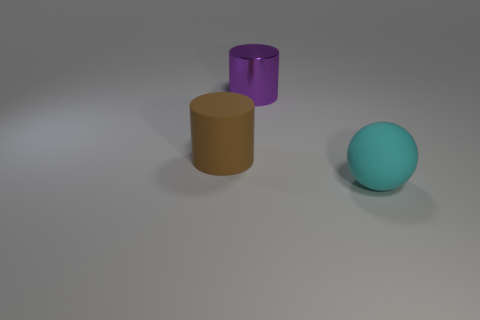Subtract all cyan cylinders. Subtract all brown balls. How many cylinders are left? 2 Add 1 rubber balls. How many objects exist? 4 Subtract all cylinders. How many objects are left? 1 Add 3 large cyan spheres. How many large cyan spheres exist? 4 Subtract 0 gray cylinders. How many objects are left? 3 Subtract all blue things. Subtract all big cylinders. How many objects are left? 1 Add 2 cyan rubber spheres. How many cyan rubber spheres are left? 3 